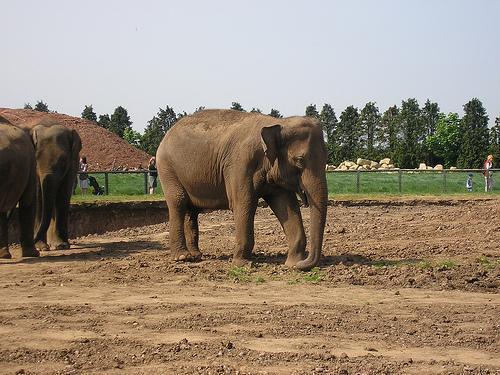How many elephants are shown?
Give a very brief answer. 3. How many elephant faces are visible?
Give a very brief answer. 2. 